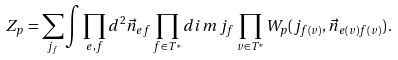Convert formula to latex. <formula><loc_0><loc_0><loc_500><loc_500>Z _ { p } = \sum _ { j _ { f } } \int \prod _ { e , f } d ^ { 2 } \vec { n } _ { e f } \prod _ { f \in T ^ { * } } d i m \, j _ { f } \prod _ { v \in T ^ { * } } W _ { p } ( j _ { f ( v ) } , \vec { n } _ { e ( v ) f ( v ) } ) \, .</formula> 